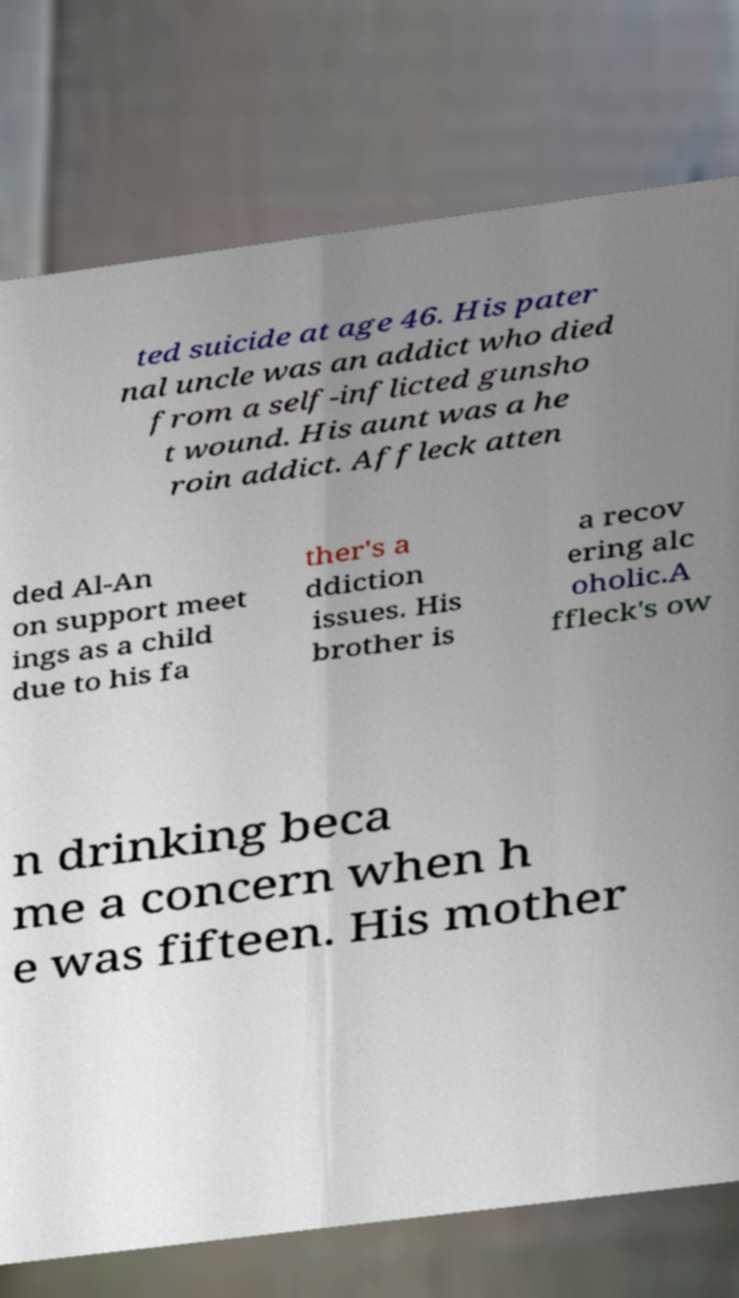What messages or text are displayed in this image? I need them in a readable, typed format. ted suicide at age 46. His pater nal uncle was an addict who died from a self-inflicted gunsho t wound. His aunt was a he roin addict. Affleck atten ded Al-An on support meet ings as a child due to his fa ther's a ddiction issues. His brother is a recov ering alc oholic.A ffleck's ow n drinking beca me a concern when h e was fifteen. His mother 